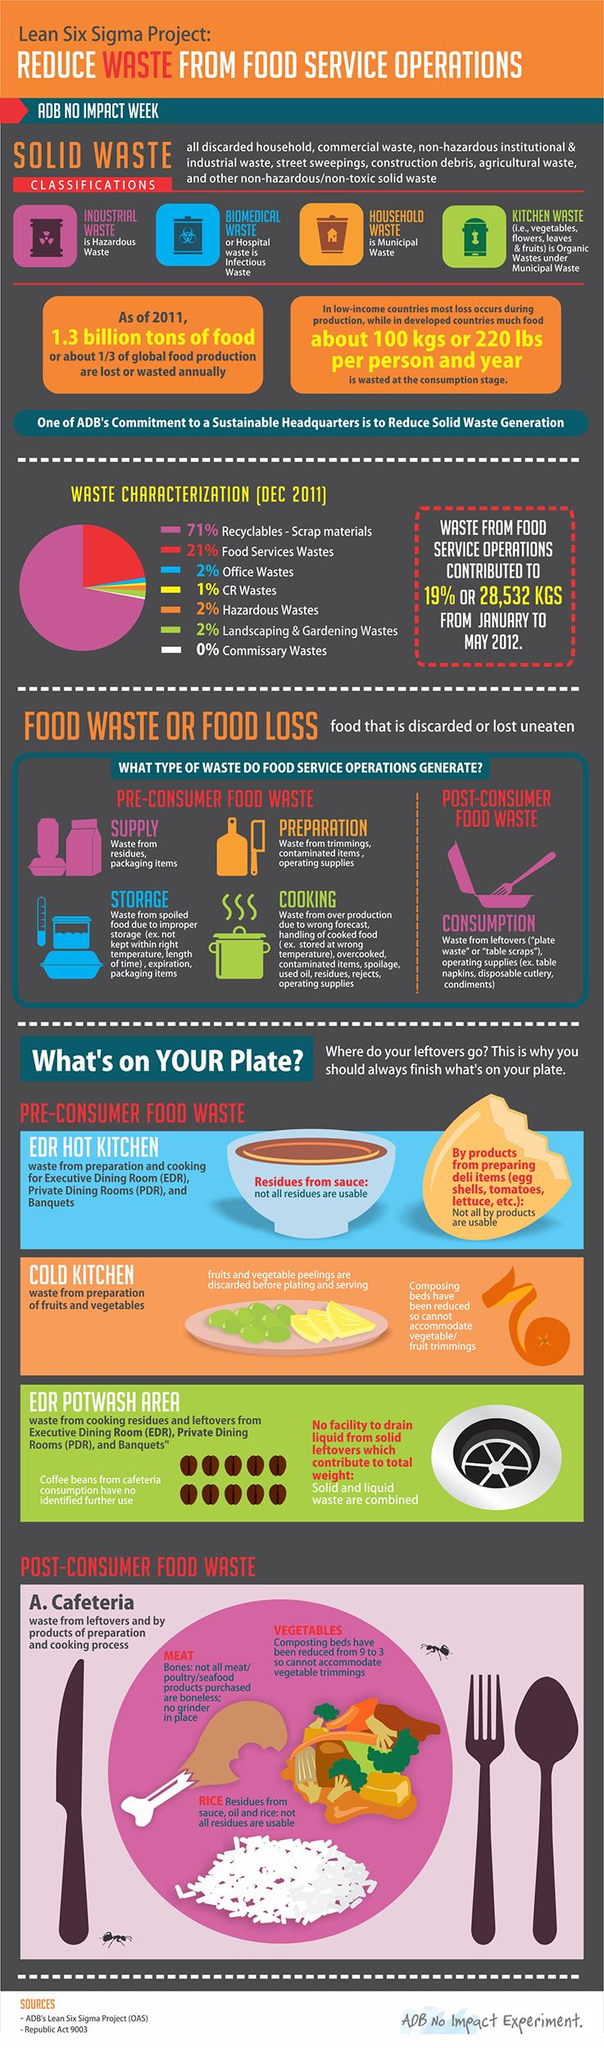Point out several critical features in this image. All municipal wastes include household waste and kitchen waste. The infographic mentions 4 instances of pre-consumer food waste. Post-consumer food waste is the name given to food that has been discarded by consumers after it has been consumed. Food services waste has the highest share of recyclable and scrap materials, compared to other industries. Biomedical waste is also known as hospital waste. 